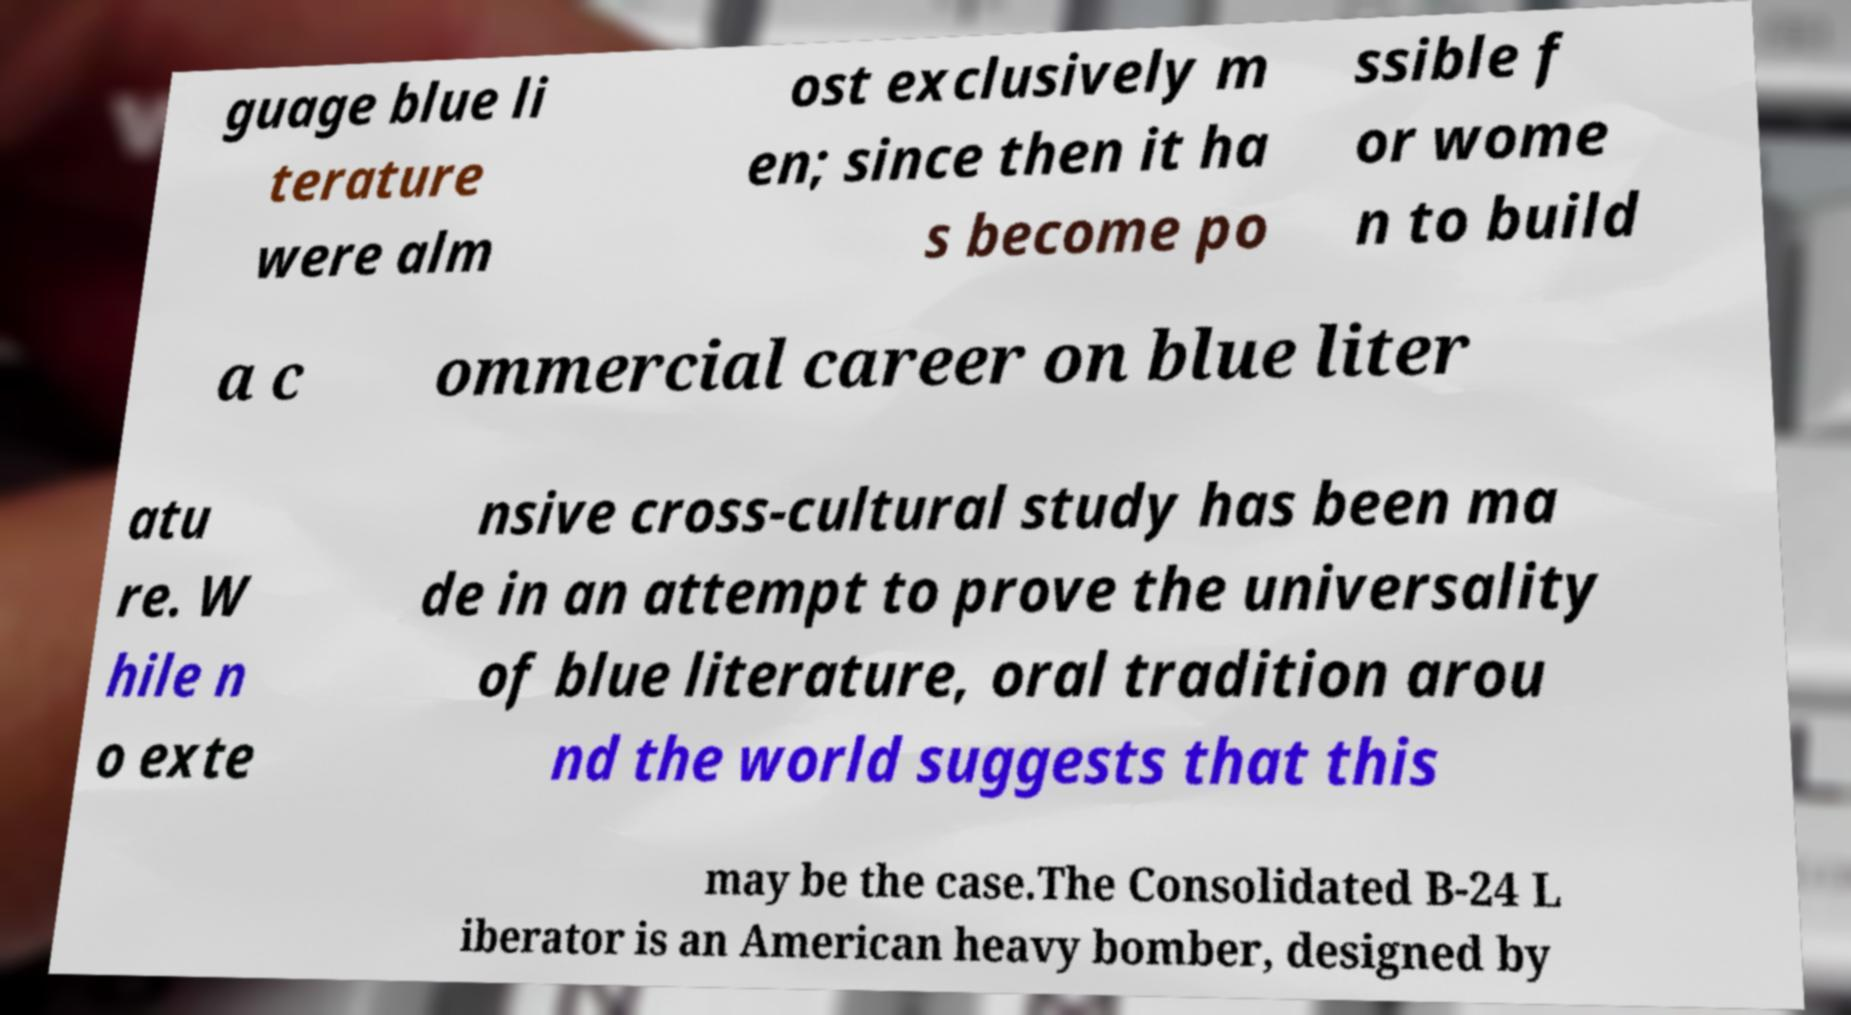What messages or text are displayed in this image? I need them in a readable, typed format. guage blue li terature were alm ost exclusively m en; since then it ha s become po ssible f or wome n to build a c ommercial career on blue liter atu re. W hile n o exte nsive cross-cultural study has been ma de in an attempt to prove the universality of blue literature, oral tradition arou nd the world suggests that this may be the case.The Consolidated B-24 L iberator is an American heavy bomber, designed by 